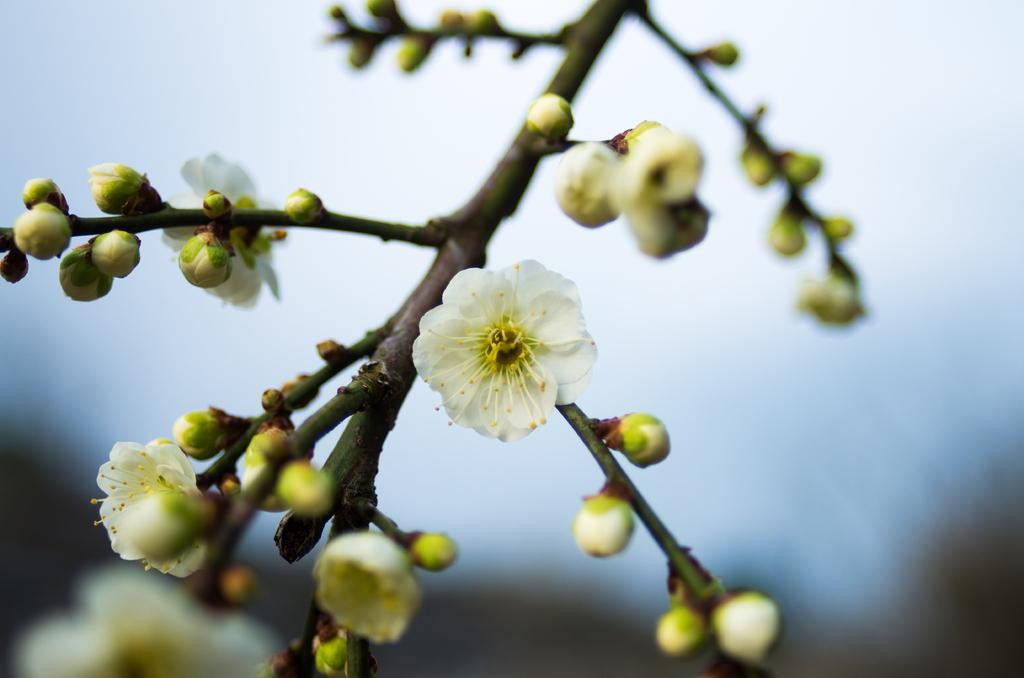What type of flowers can be seen in the image? There are white color flowers in the image. Can you describe the stage of development of some of the flowers? Yes, there are buds in the image. What is the appearance of the background in the image? The background of the image is blurred. What type of tax is being discussed in the image? There is no discussion of tax in the image; it features white color flowers and buds with a blurred background. 